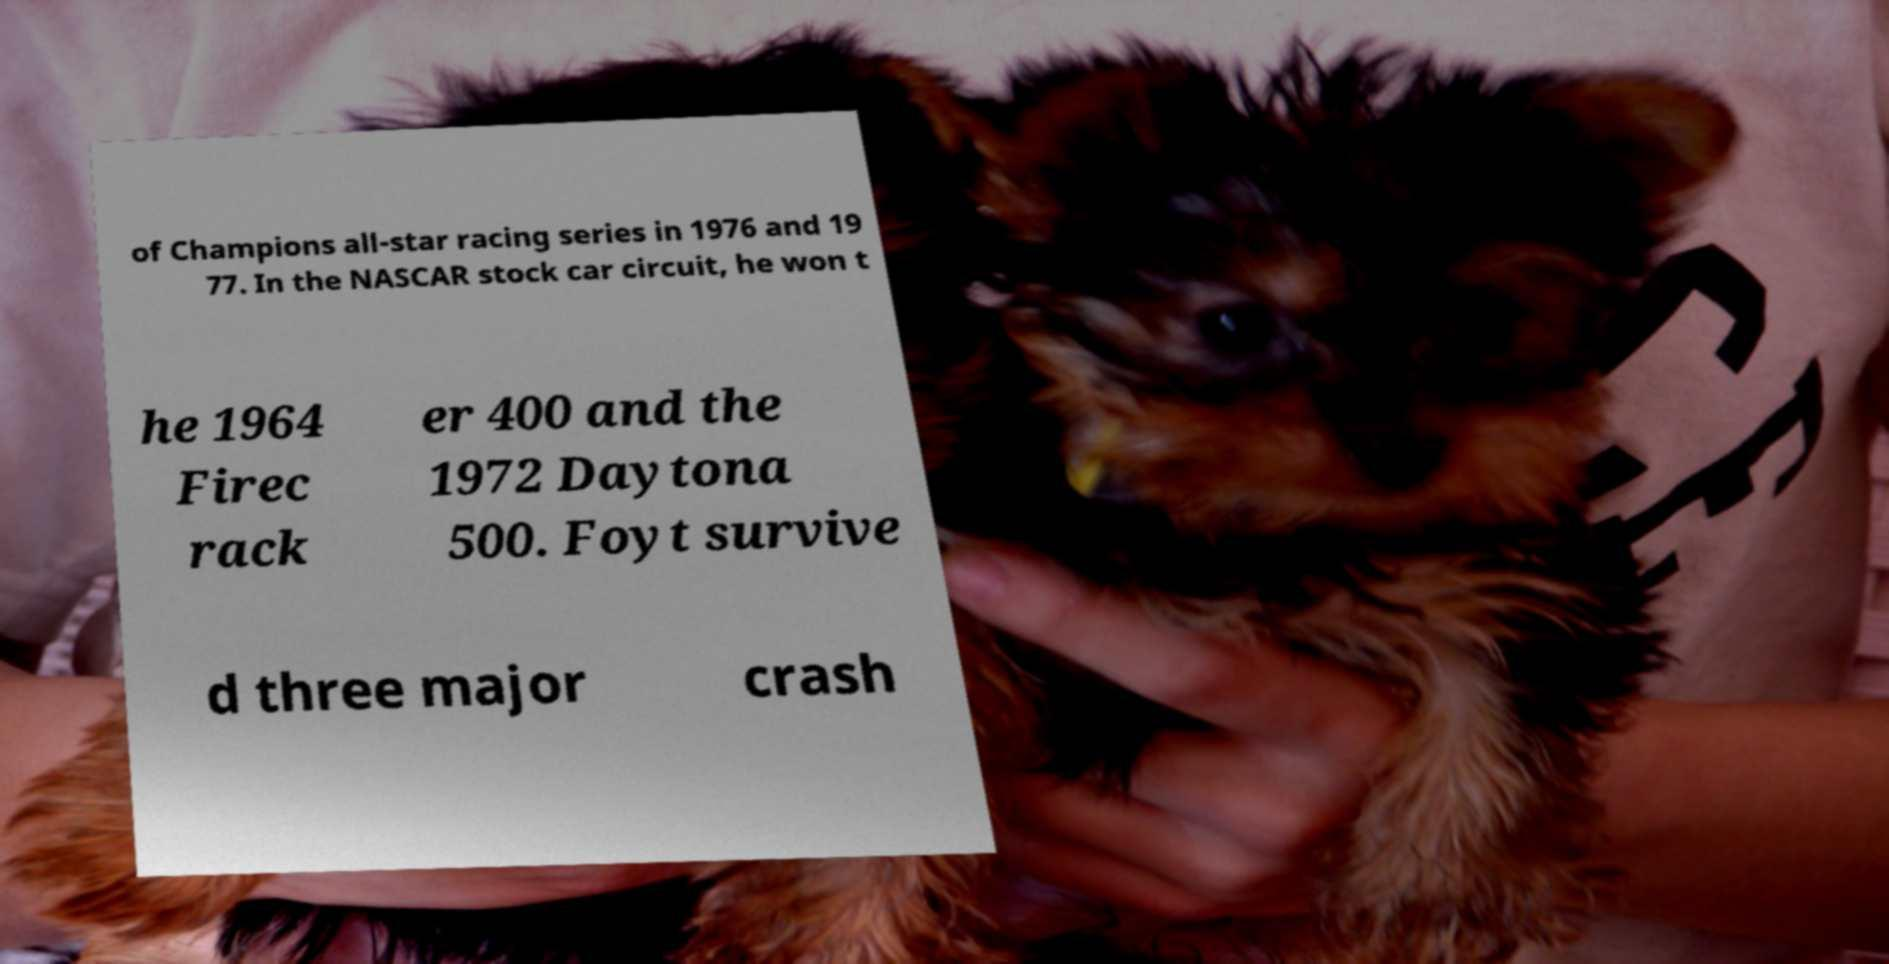For documentation purposes, I need the text within this image transcribed. Could you provide that? of Champions all-star racing series in 1976 and 19 77. In the NASCAR stock car circuit, he won t he 1964 Firec rack er 400 and the 1972 Daytona 500. Foyt survive d three major crash 